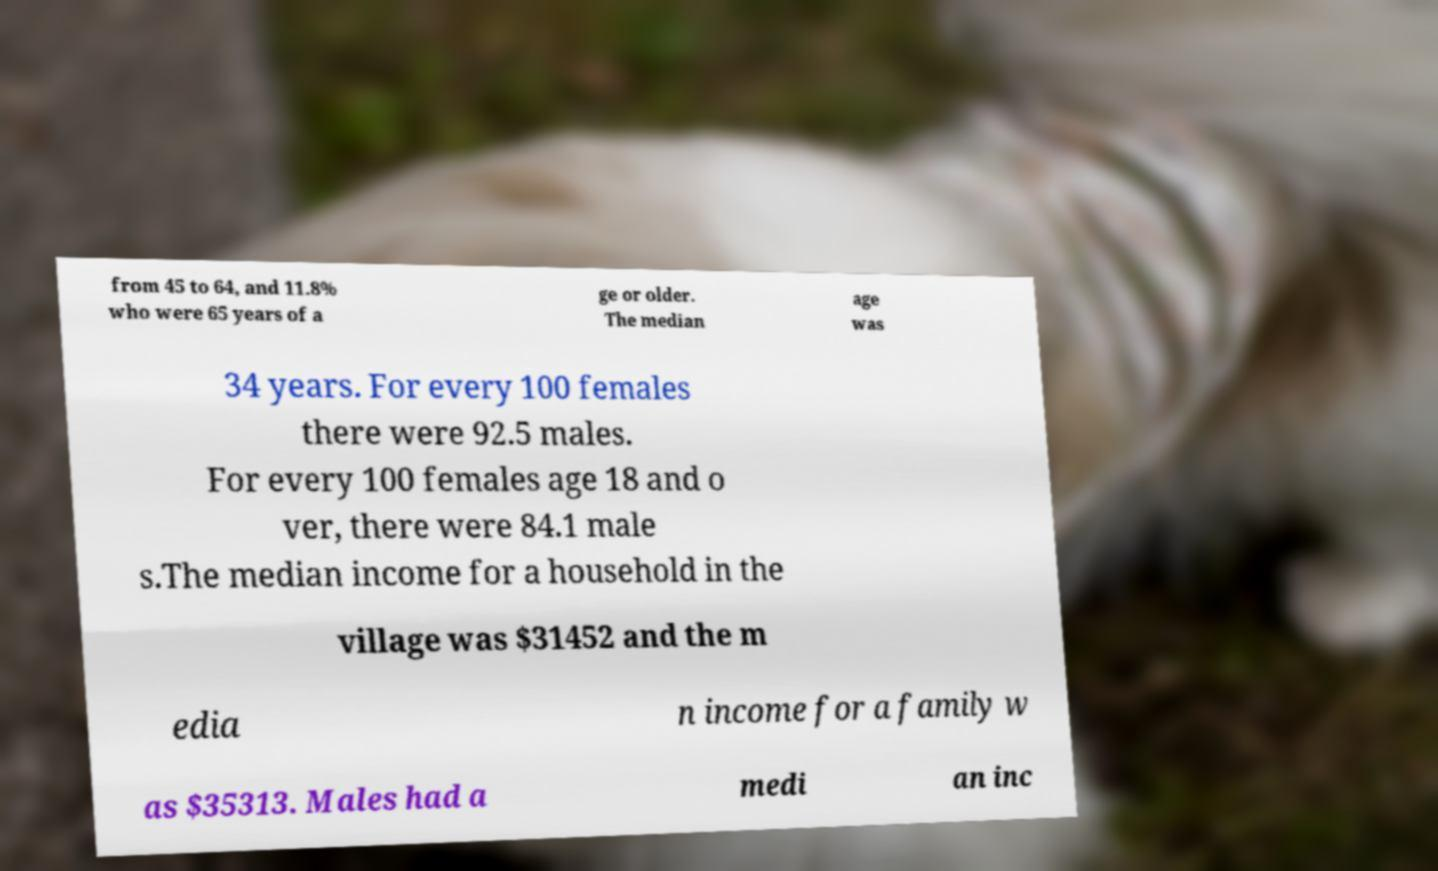I need the written content from this picture converted into text. Can you do that? from 45 to 64, and 11.8% who were 65 years of a ge or older. The median age was 34 years. For every 100 females there were 92.5 males. For every 100 females age 18 and o ver, there were 84.1 male s.The median income for a household in the village was $31452 and the m edia n income for a family w as $35313. Males had a medi an inc 